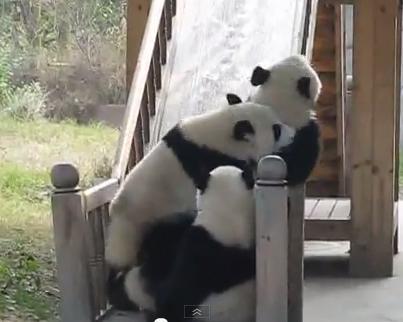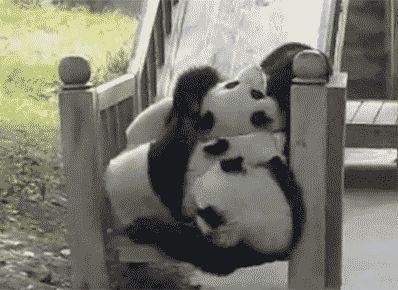The first image is the image on the left, the second image is the image on the right. For the images displayed, is the sentence "There are two pandas with some visible space between them." factually correct? Answer yes or no. No. The first image is the image on the left, the second image is the image on the right. For the images shown, is this caption "An image shows at least two pandas falling backward down a slide with gray banisters." true? Answer yes or no. Yes. 